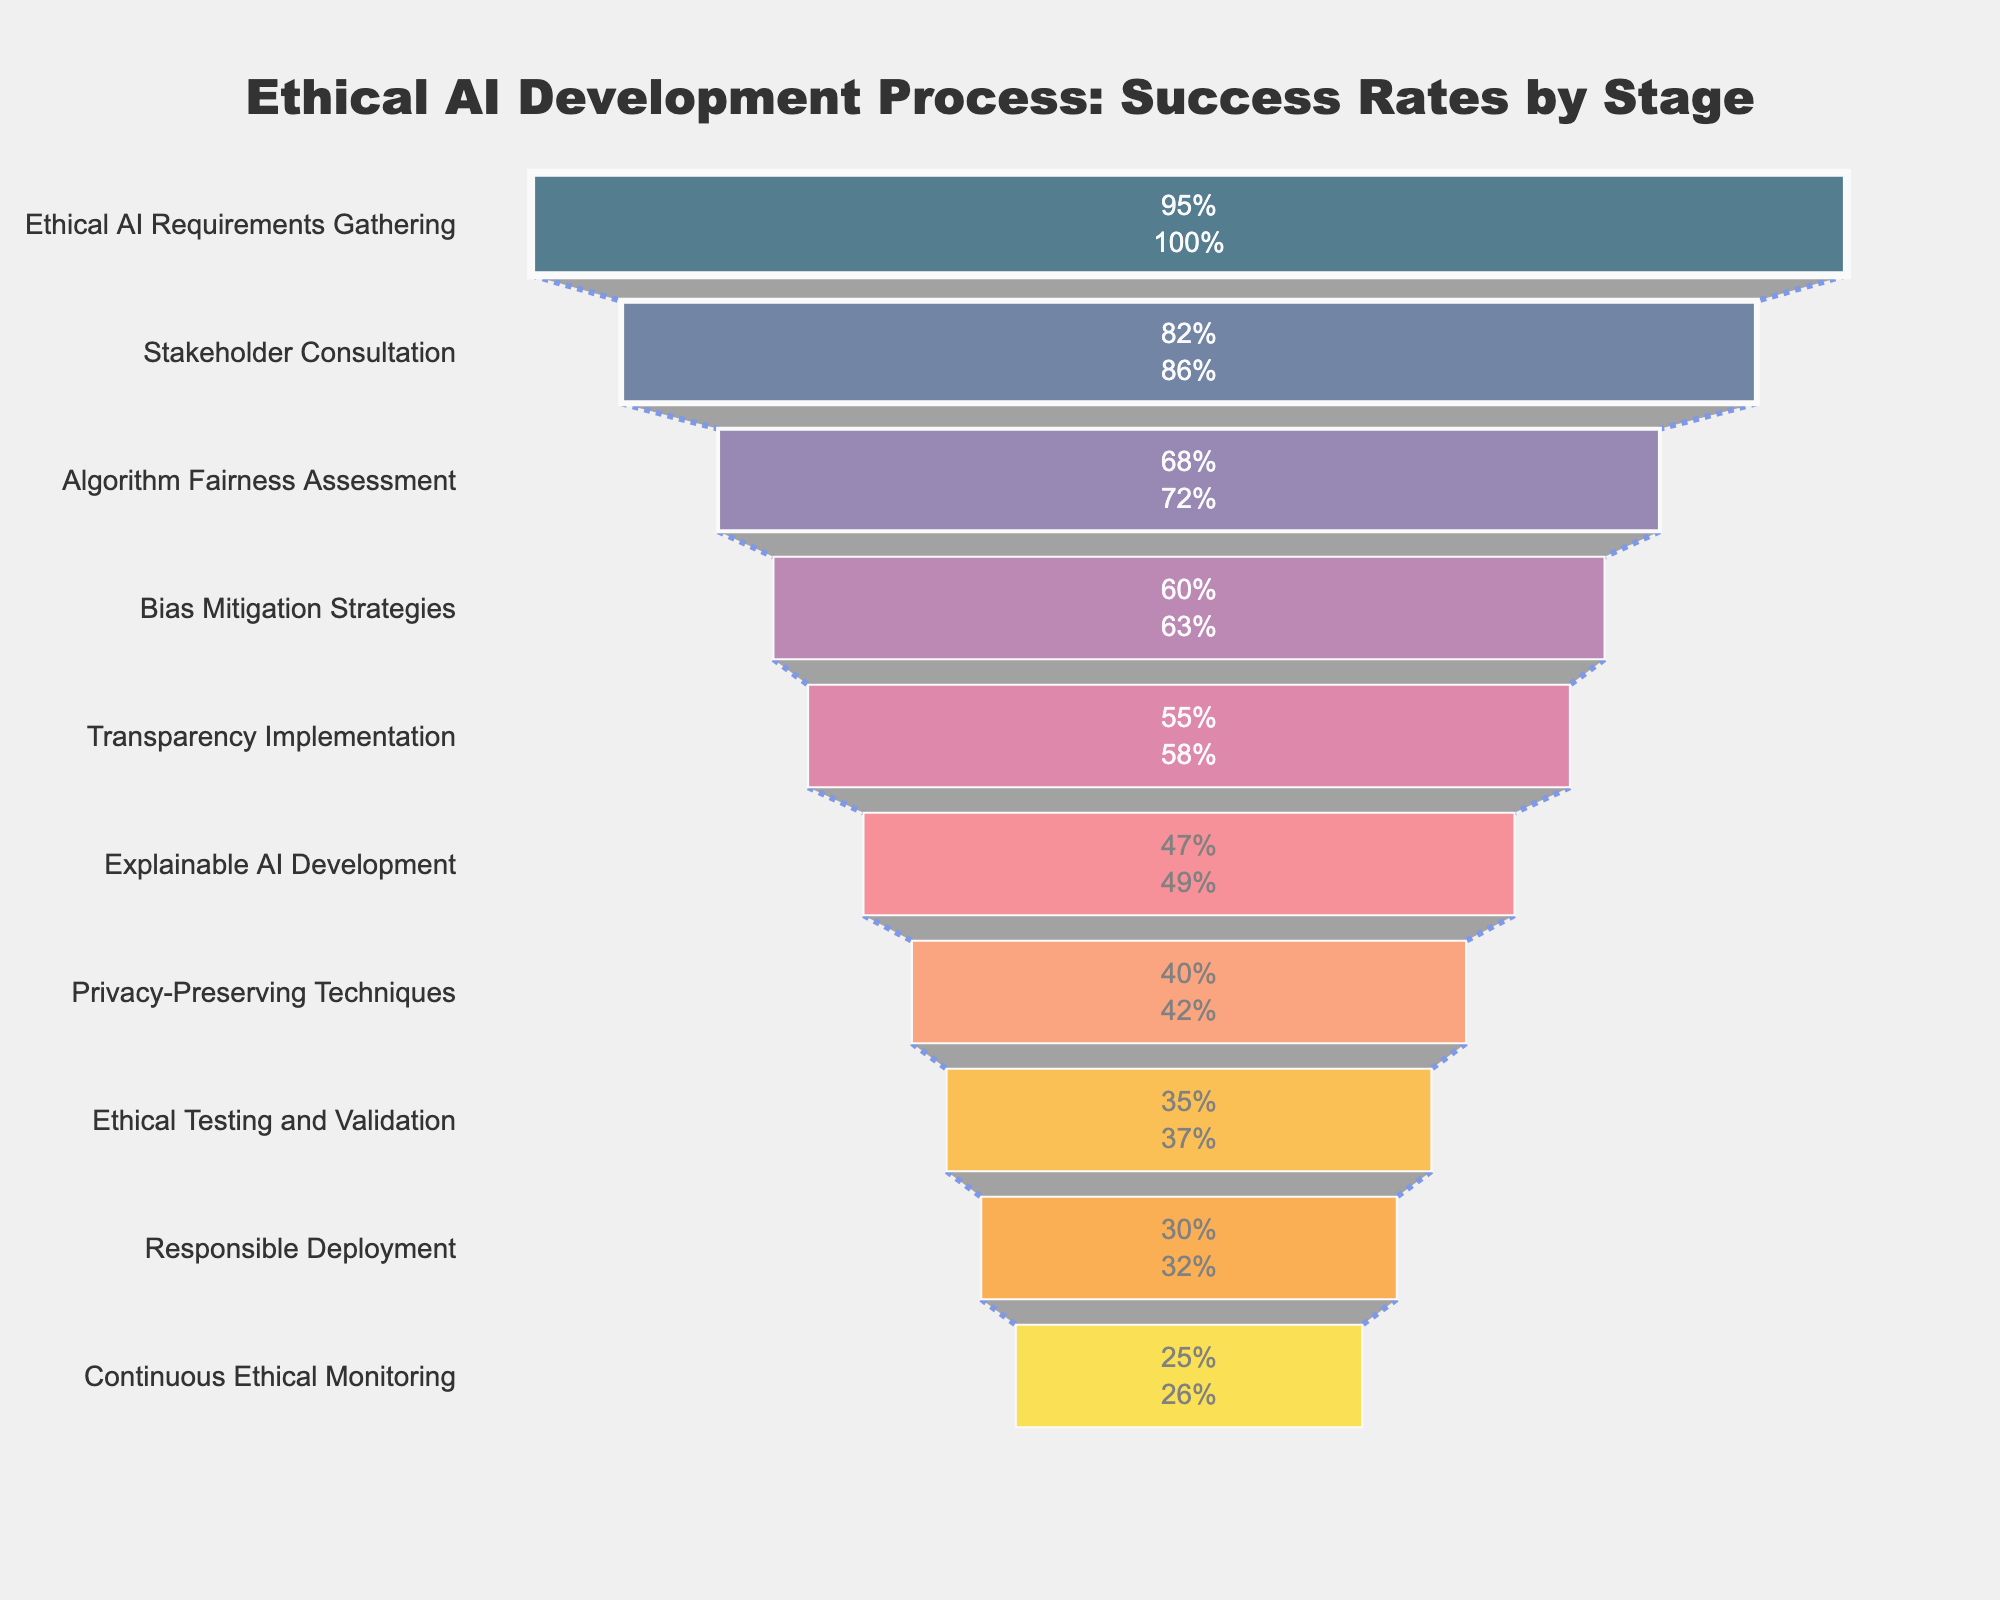what is the title of the figure? The title can usually be found at the top of the figure. In this case, it says "Ethical AI Development Process: Success Rates by Stage."
Answer: Ethical AI Development Process: Success Rates by Stage How many stages are included in the funnel chart? By counting the stages listed along the y-axis, we can see there are ten stages in total.
Answer: Ten Which stage has the highest success rate? The stage at the top of the funnel chart represents the highest success rate. In this case, it is the "Ethical AI Requirements Gathering" stage with a success rate of 95%.
Answer: Ethical AI Requirements Gathering How does the success rate of "Bias Mitigation Strategies" compare to "Explainable AI Development"? We compare the success rates of these two stages: "Bias Mitigation Strategies" has a success rate of 60%, while "Explainable AI Development" has a success rate of 47%. Therefore, "Bias Mitigation Strategies" has a higher success rate.
Answer: Bias Mitigation Strategies What is the overall trend of success rates as we move from the top to the bottom of the funnel chart? Observing the funnel chart from top to bottom, the success rates progressively decrease from 95% at the top down to 25% at the bottom.
Answer: Decreasing What is the percentage difference between "Transparency Implementation" and "Privacy-Preserving Techniques"? "Transparency Implementation" has a success rate of 55%, and "Privacy-Preserving Techniques" has a success rate of 40%. The percentage difference is calculated as 55% - 40% = 15%.
Answer: 15% What is the combined success rate of the first three stages? The success rates of the first three stages are 95%, 82%, and 68%. Adding these together gives 95 + 82 + 68 = 245%.
Answer: 245% Which stage has the closest success rate to 45%? Looking at the stages, "Explainable AI Development" has a success rate of 47%, which is the closest to 45%.
Answer: Explainable AI Development What is the median success rate among all stages? To find the median, we list all success rates in ascending order: 25, 30, 35, 40, 47, 55, 60, 68, 82, 95. The median is the average of the two middle values in this sorted list, which are 47% and 55%, so (47 + 55) / 2 = 51%.
Answer: 51% How much higher is the success rate of "Responsible Deployment" compared to "Continuous Ethical Monitoring"? "Responsible Deployment" has a success rate of 30%, while "Continuous Ethical Monitoring" has a success rate of 25%. The difference is 30% - 25% = 5%.
Answer: 5% 